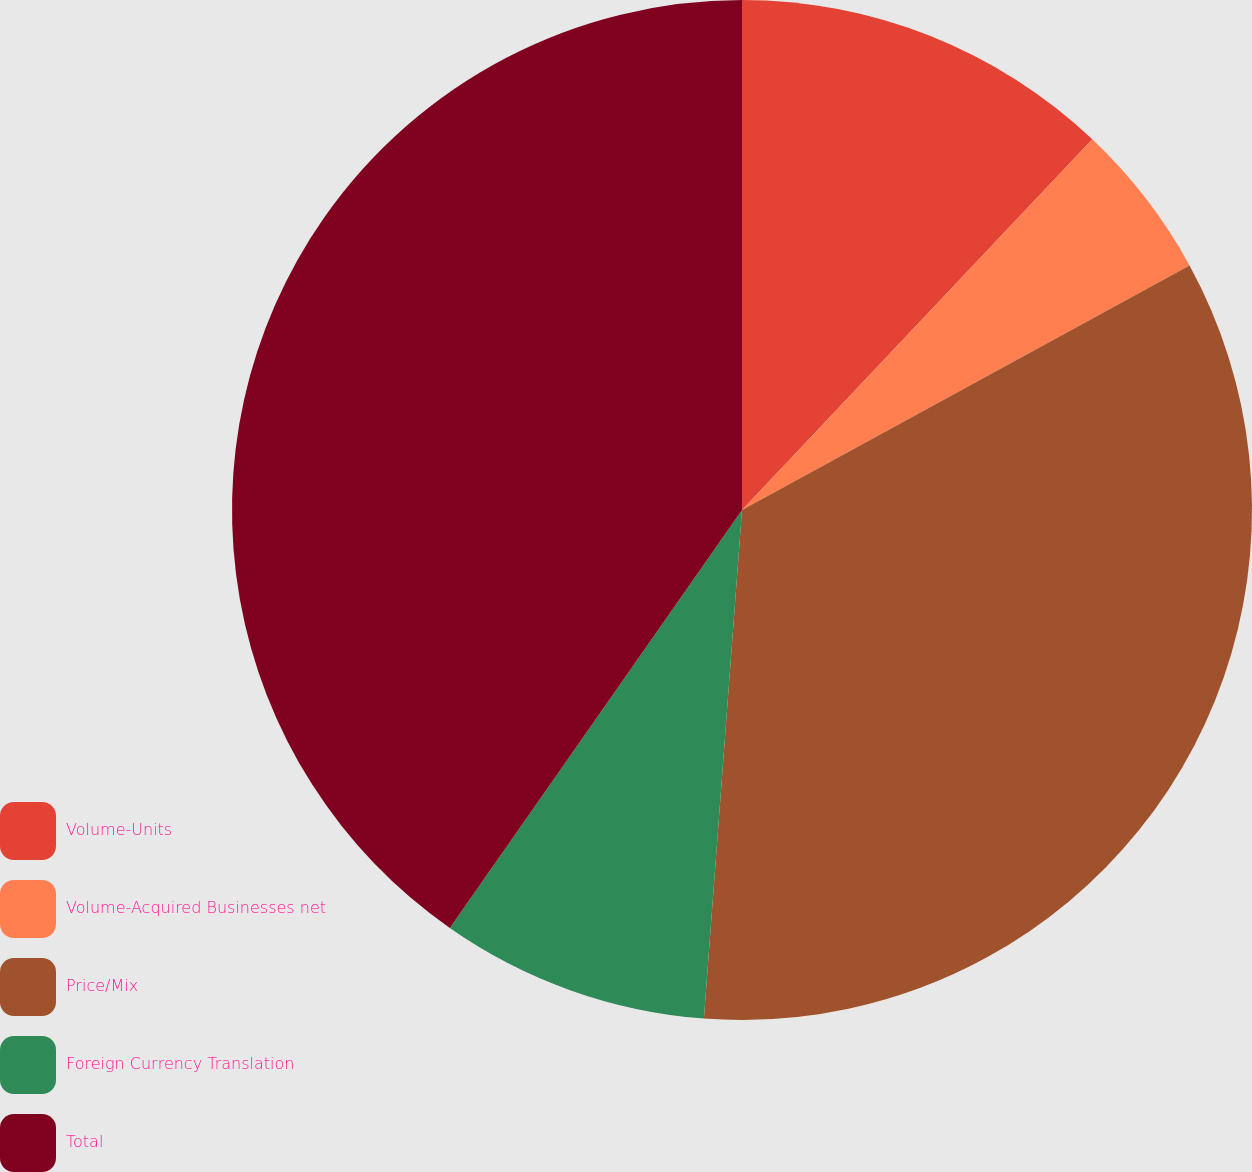Convert chart. <chart><loc_0><loc_0><loc_500><loc_500><pie_chart><fcel>Volume-Units<fcel>Volume-Acquired Businesses net<fcel>Price/Mix<fcel>Foreign Currency Translation<fcel>Total<nl><fcel>12.05%<fcel>4.99%<fcel>34.15%<fcel>8.52%<fcel>40.29%<nl></chart> 